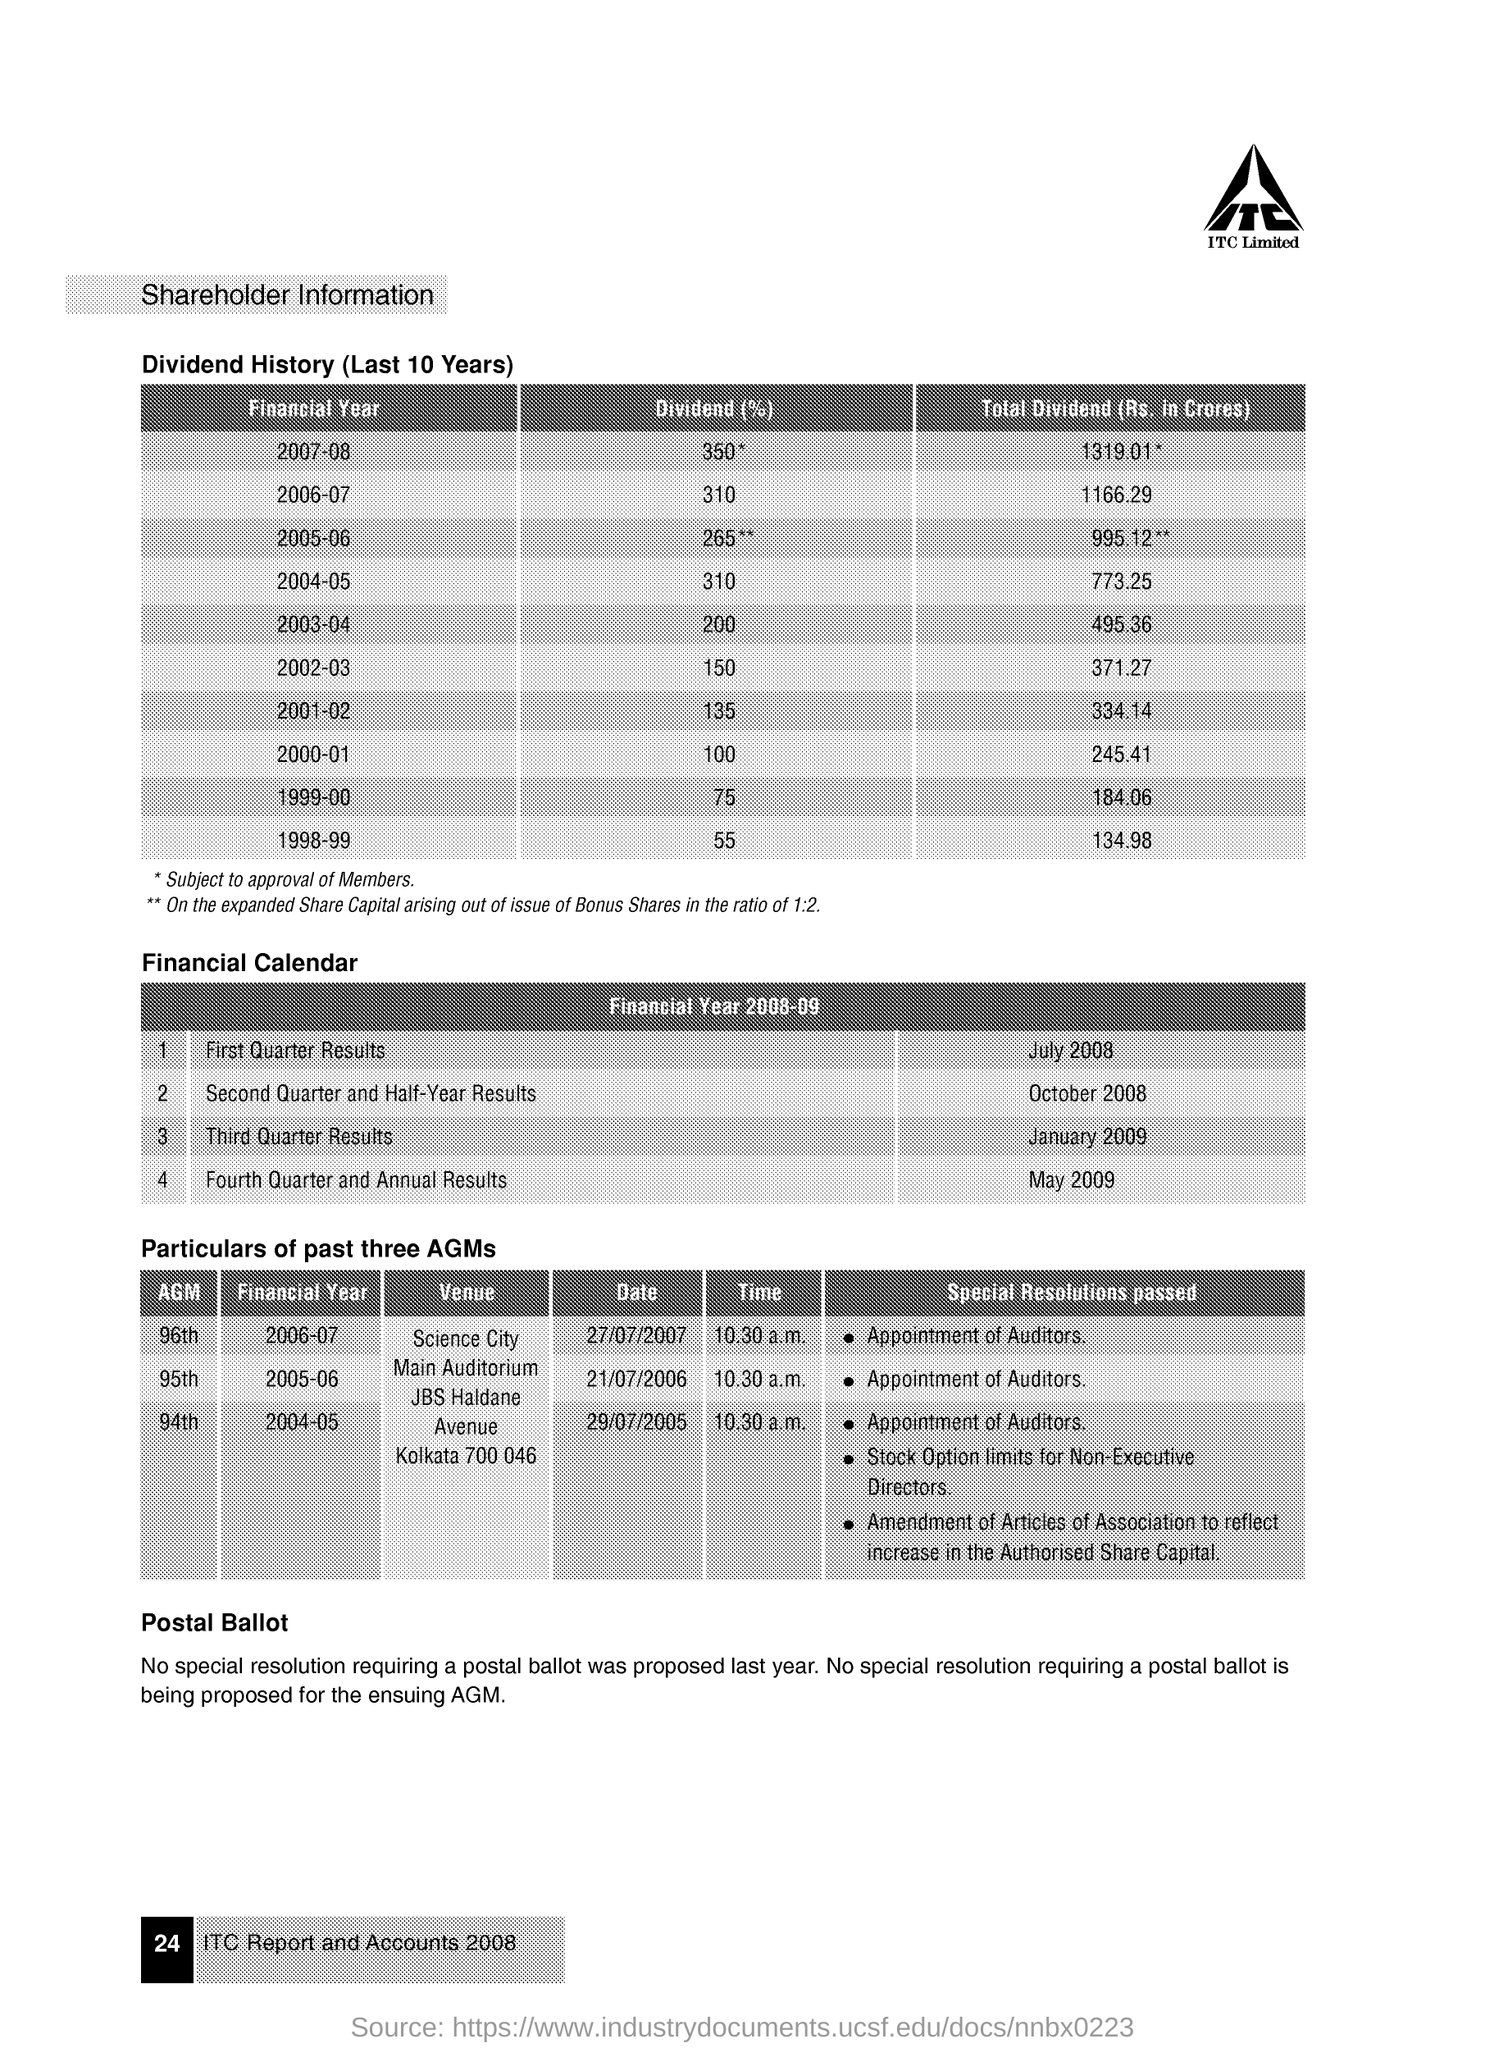List a handful of essential elements in this visual. The dividend, expressed as a percentage, for the financial year 2000-01 was 100. At the 96th Annual General Meeting (AGM) held during the financial year 2006-07, special resolutions were passed, including the appointment of auditors. The first quarter results were released in July 2008. The dividend as a percentage for the financial year 2002-03 is 150.. The total dividend for the financial year 2003-04 was Rs 495.36 crores. 